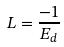Convert formula to latex. <formula><loc_0><loc_0><loc_500><loc_500>L = \frac { - 1 } { E _ { d } }</formula> 